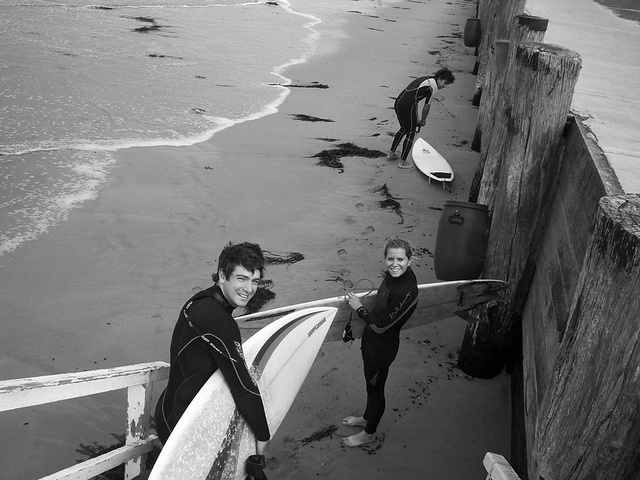Describe the objects in this image and their specific colors. I can see people in darkgray, black, gray, and lightgray tones, surfboard in darkgray, lightgray, gray, and black tones, surfboard in darkgray, black, gray, and lightgray tones, people in darkgray, black, gray, and lightgray tones, and people in darkgray, black, gray, and lightgray tones in this image. 